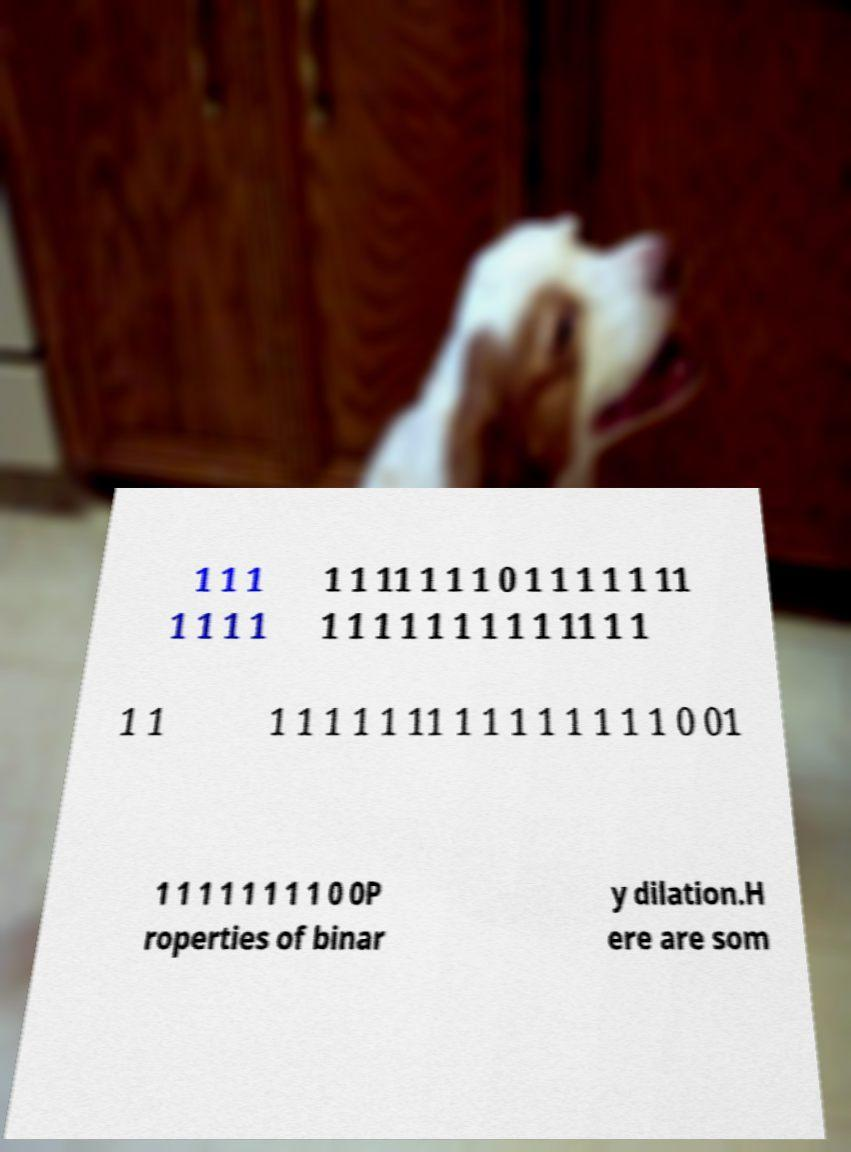There's text embedded in this image that I need extracted. Can you transcribe it verbatim? 1 1 1 1 1 1 1 1 1 11 1 1 1 0 1 1 1 1 1 11 1 1 1 1 1 1 1 1 1 11 1 1 1 1 1 1 1 1 1 11 1 1 1 1 1 1 1 1 0 01 1 1 1 1 1 1 1 1 0 0P roperties of binar y dilation.H ere are som 